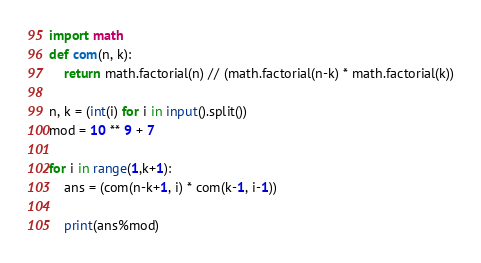Convert code to text. <code><loc_0><loc_0><loc_500><loc_500><_Python_>import math
def com(n, k):
    return math.factorial(n) // (math.factorial(n-k) * math.factorial(k))

n, k = (int(i) for i in input().split())
mod = 10 ** 9 + 7

for i in range(1,k+1):
    ans = (com(n-k+1, i) * com(k-1, i-1))

    print(ans%mod)</code> 